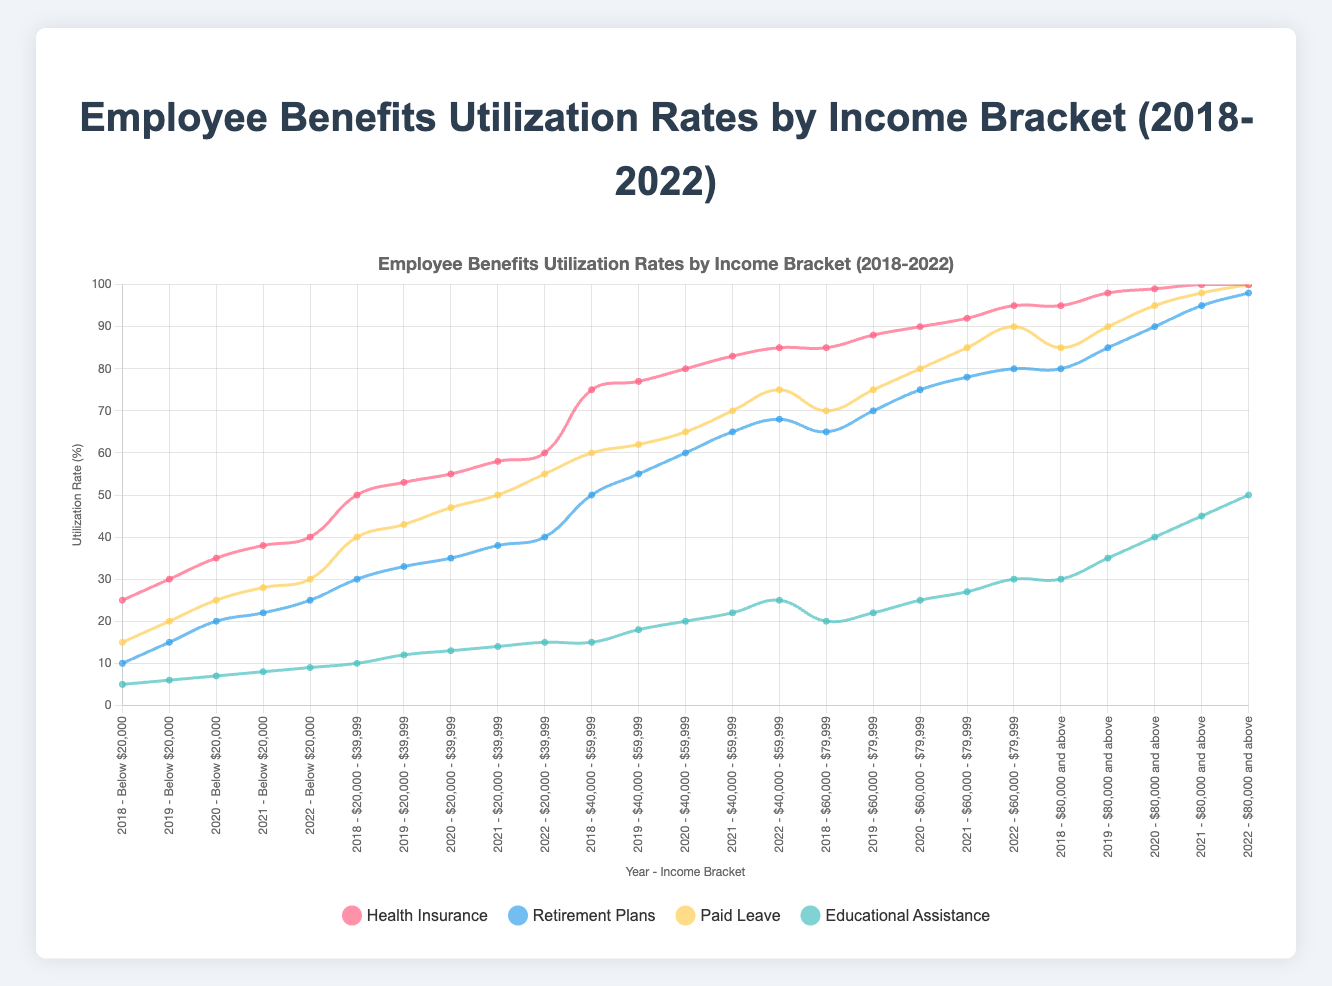What is the Employee Benefits Utilization Rate for Health Insurance in the "$40,000 - $59,999" income bracket in the year 2020? Look for the 2020 data for the "$40,000 - $59,999" income bracket for Health Insurance. The rate is 80% as per the data.
Answer: 80% Which year had the highest overall utilization rate for Paid Leave for the "Below $20,000" income bracket? Compare the Paid Leave rates from 2018 to 2022 for the "Below $20,000" bracket. The highest rate is 30% in 2022.
Answer: 2022 Did Educational Assistance utilization rates increase or decrease in the "$60,000 - $79,999" income bracket from 2018 to 2022? Observe the trend for Educational Assistance from 2018 to 2022 in the "$60,000 - $79,999" income bracket, which increased from 20% in 2018 to 30% in 2022.
Answer: Increased In 2021, which income bracket had the highest Retirement Plans utilization rate? Compare the 2021 Retirement Plans utilization rates across all income brackets. The "$80,000 and above" bracket had the highest rate at 95%.
Answer: $80,000 and above How did Health Insurance utilization rates change over time in the "Below $20,000" income bracket from 2018 to 2022? Trace the Health Insurance data from 2018 to 2022 in the "Below $20,000" bracket. The rates increased each year from 25% in 2018 to 40% in 2022.
Answer: Increased Which benefit had the lowest overall utilization rate in the "$20,000 - $39,999" income bracket across all years? Examine all benefit rates from 2018 to 2022 for the "$20,000 - $39,999" bracket. Educational Assistance consistently had the lowest rates.
Answer: Educational Assistance What's the difference in Paid Leave utilization rates between the "$20,000 - $39,999" and "$80,000 and above" income brackets in 2019? Subtract the Paid Leave rate of the "$20,000 - $39,999" bracket (43%) from that of the "$80,000 and above" bracket (90%) in 2019. The difference is 47%.
Answer: 47% Which income bracket saw the largest increase in Retirement Plans utilization from 2018 to 2022? Calculate the increase in Retirement Plans rates from 2018 to 2022 for each bracket. The "$80,000 and above" bracket saw the largest increase, from 80% to 98%, an 18% increase.
Answer: $80,000 and above What is the average Health Insurance utilization rate for the "$60,000 - $79,999" income bracket from 2018 to 2022? Sum the yearly Health Insurance rates for "$60,000 - $79,999" from 2018 to 2022 (85+88+90+92+95 = 450). Divide by 5 for the average (450/5).
Answer: 90% How does the Retirement Plans utilization rate in 2020 for the "$40,000 - $59,999" income bracket compare to the same bracket's rate in 2022? Compare the 2020 rate (60%) with the 2022 rate (68%). The rate in 2022 is higher than in 2020.
Answer: 2022 is higher 